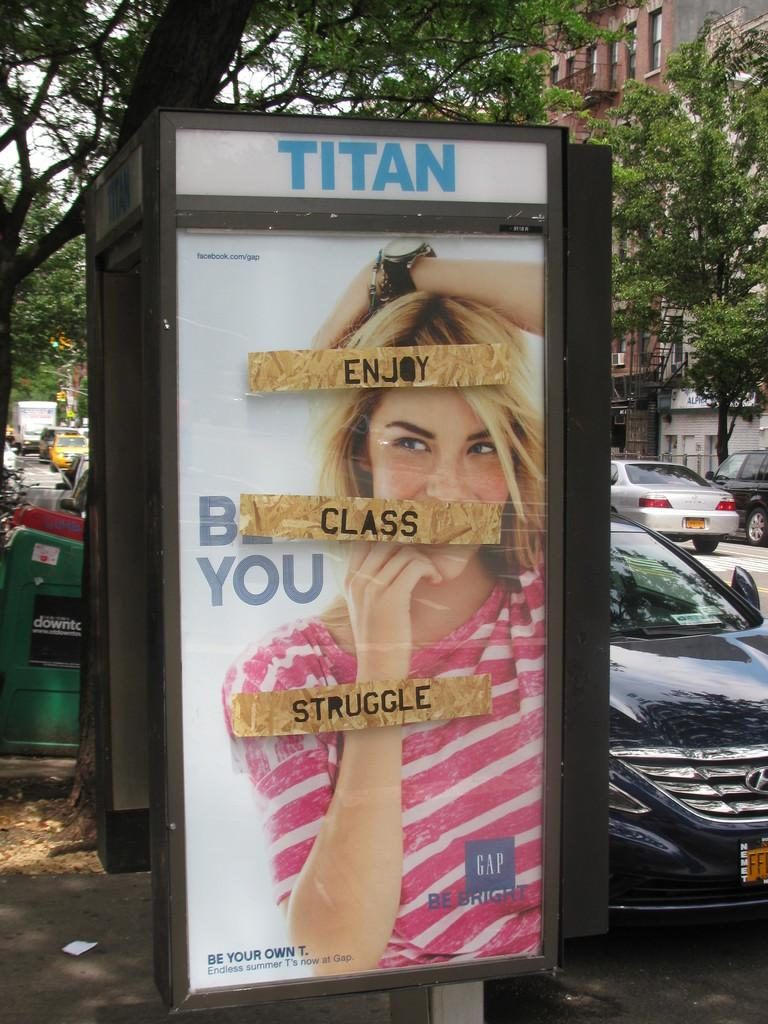What is the main subject in the middle of the image? There is a poster in the middle of the image. What is depicted on the poster? The poster features a woman. What is the woman wearing? The woman is wearing a pink t-shirt. What else can be seen on the poster besides the woman? There is text on the poster. What can be seen in the background of the image? There are cars, dustbins, trees, and the sky visible in the background of the image. What type of bone can be seen in the woman's hand in the image? There is no bone visible in the woman's hand in the image. What flavor of ice cream is the woman holding in the image? There is no ice cream present in the image. 